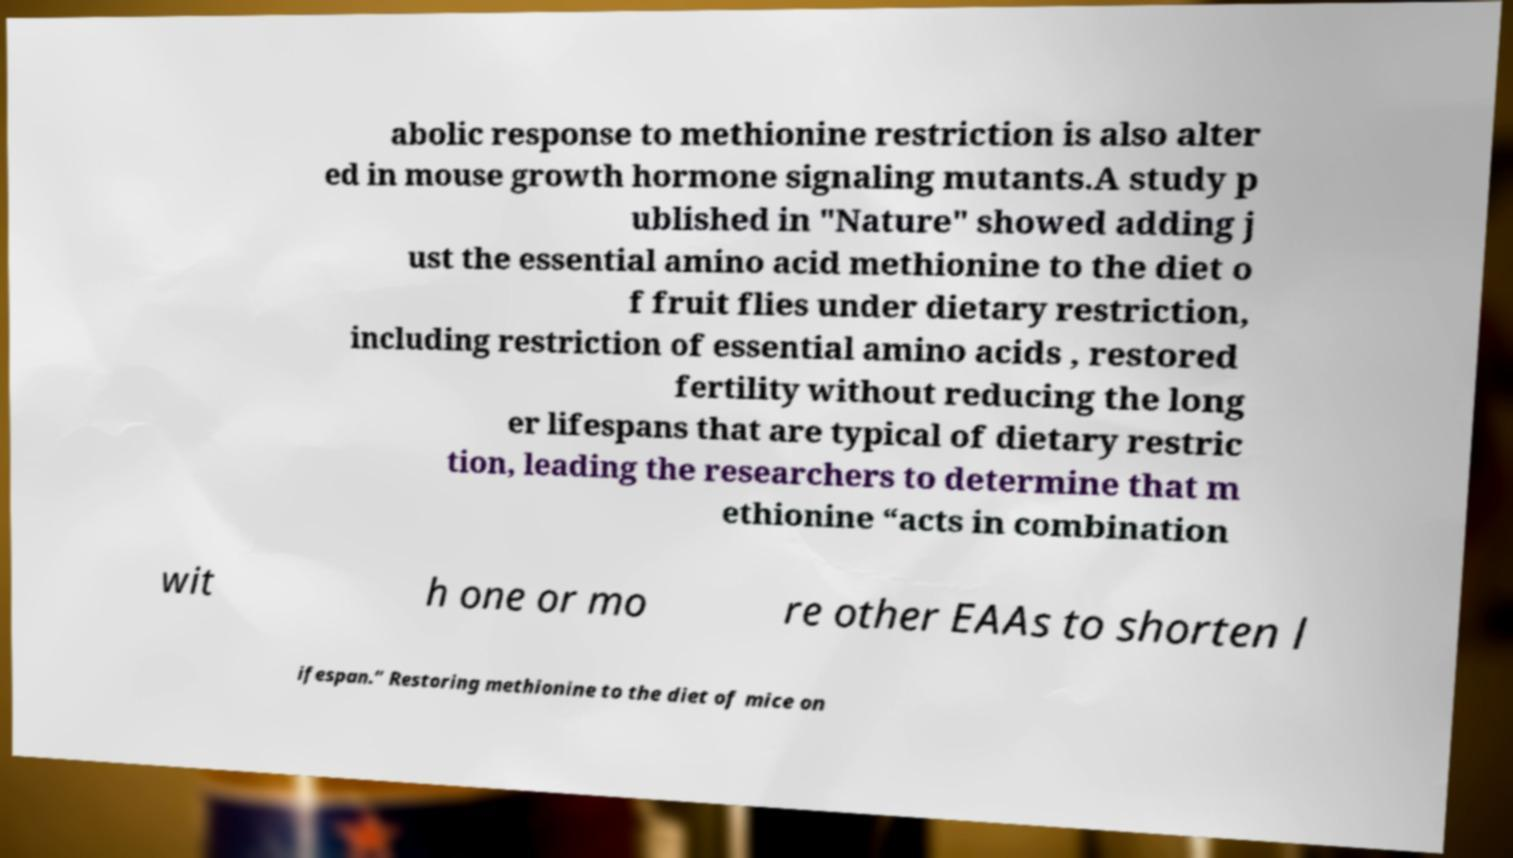Could you extract and type out the text from this image? abolic response to methionine restriction is also alter ed in mouse growth hormone signaling mutants.A study p ublished in "Nature" showed adding j ust the essential amino acid methionine to the diet o f fruit flies under dietary restriction, including restriction of essential amino acids , restored fertility without reducing the long er lifespans that are typical of dietary restric tion, leading the researchers to determine that m ethionine “acts in combination wit h one or mo re other EAAs to shorten l ifespan.” Restoring methionine to the diet of mice on 